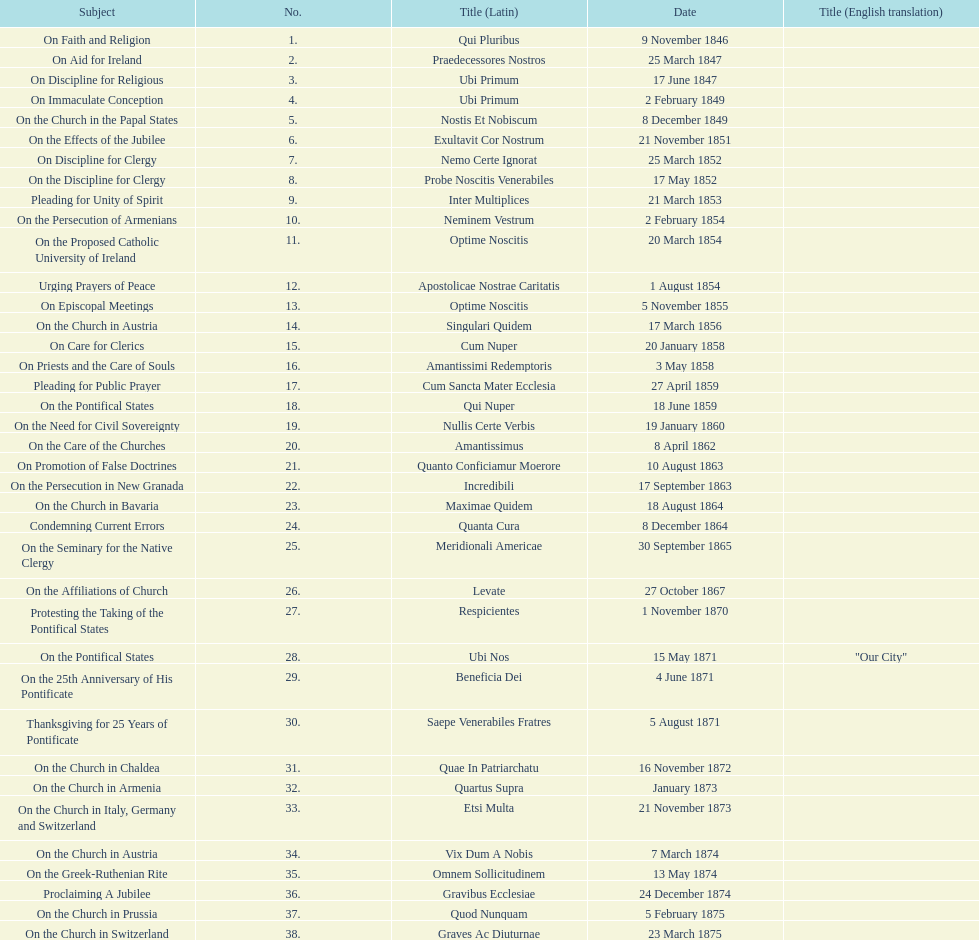In the first 10 years of his reign, how many encyclicals did pope pius ix issue? 14. 